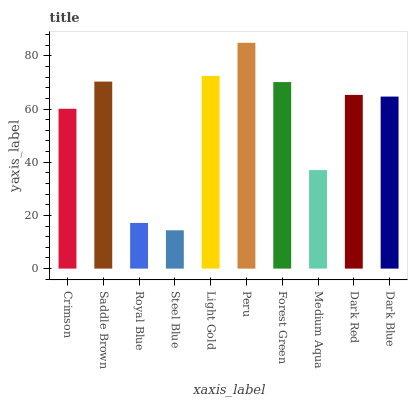Is Steel Blue the minimum?
Answer yes or no. Yes. Is Peru the maximum?
Answer yes or no. Yes. Is Saddle Brown the minimum?
Answer yes or no. No. Is Saddle Brown the maximum?
Answer yes or no. No. Is Saddle Brown greater than Crimson?
Answer yes or no. Yes. Is Crimson less than Saddle Brown?
Answer yes or no. Yes. Is Crimson greater than Saddle Brown?
Answer yes or no. No. Is Saddle Brown less than Crimson?
Answer yes or no. No. Is Dark Red the high median?
Answer yes or no. Yes. Is Dark Blue the low median?
Answer yes or no. Yes. Is Royal Blue the high median?
Answer yes or no. No. Is Royal Blue the low median?
Answer yes or no. No. 